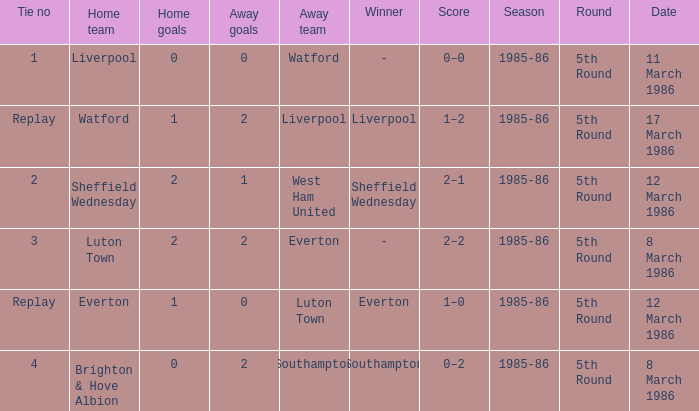What was the tie resulting from Sheffield Wednesday's game? 2.0. 